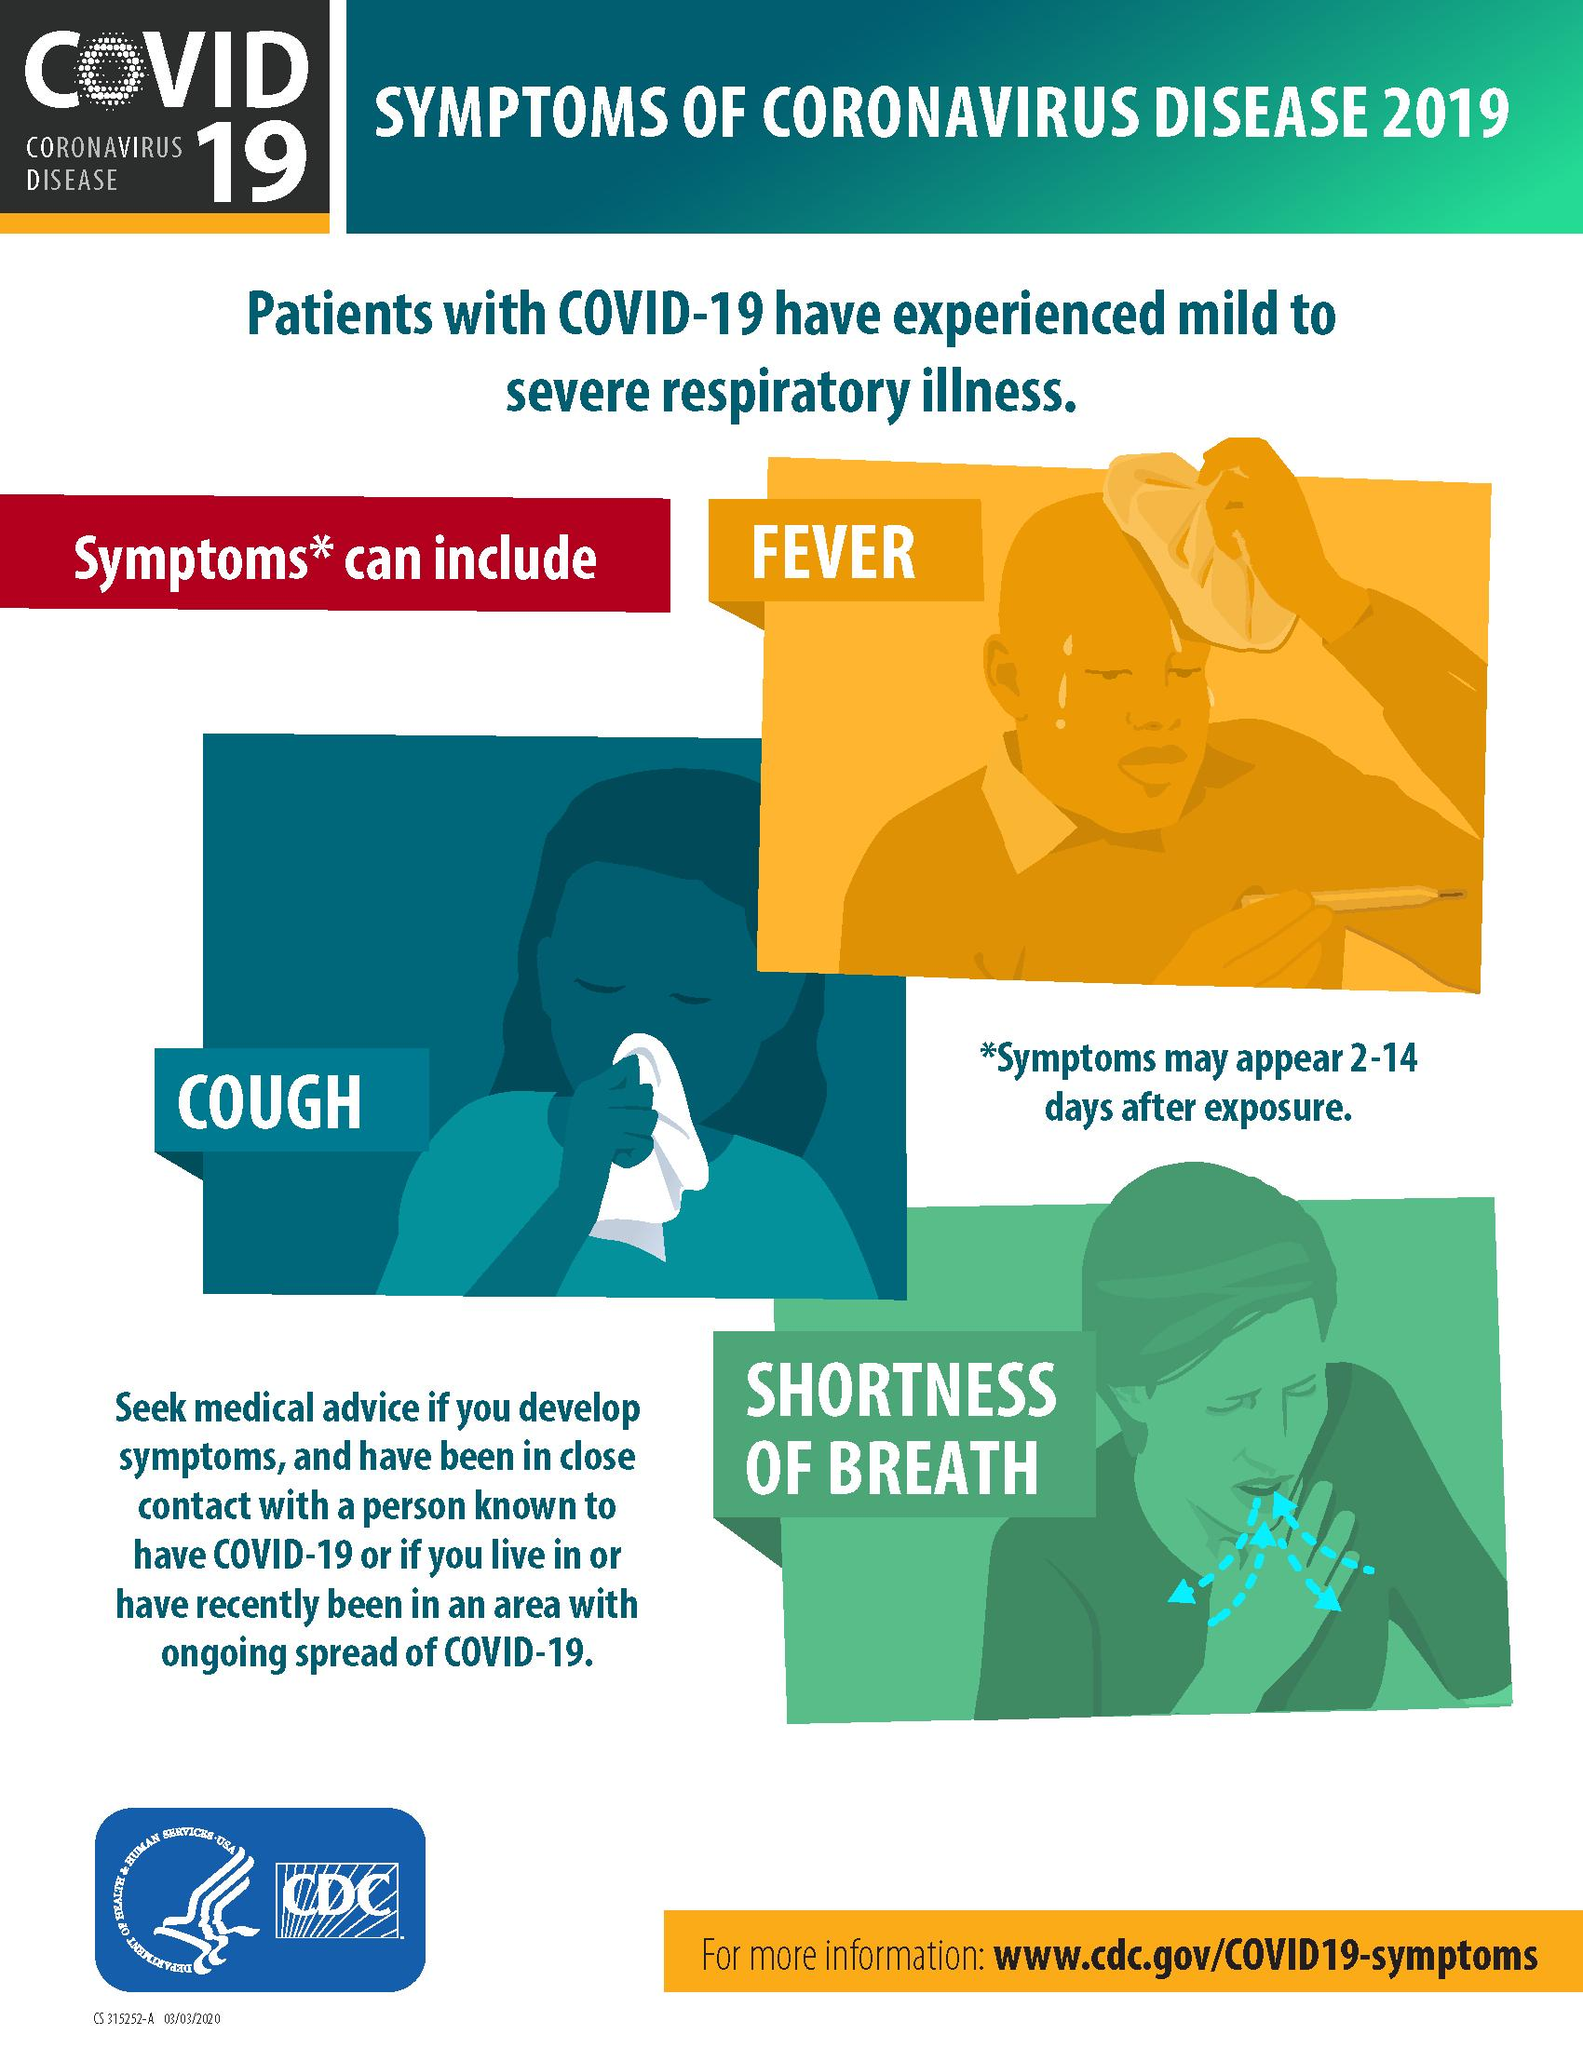Point out several critical features in this image. The background color given to the phrase "Shortness of breath" is red, orange, blue, green, and finally, green. The infographic lists shortness of breath as the third symptom of COVID-19, commonly referred to as corona. The background color assigned to "Cough" is blue, orange, red and green. The infographic contains three symptoms of COVID-19. Coronavirus can cause a range of health issues, including fever, cough, and shortness of breath. 